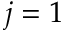Convert formula to latex. <formula><loc_0><loc_0><loc_500><loc_500>j = 1</formula> 